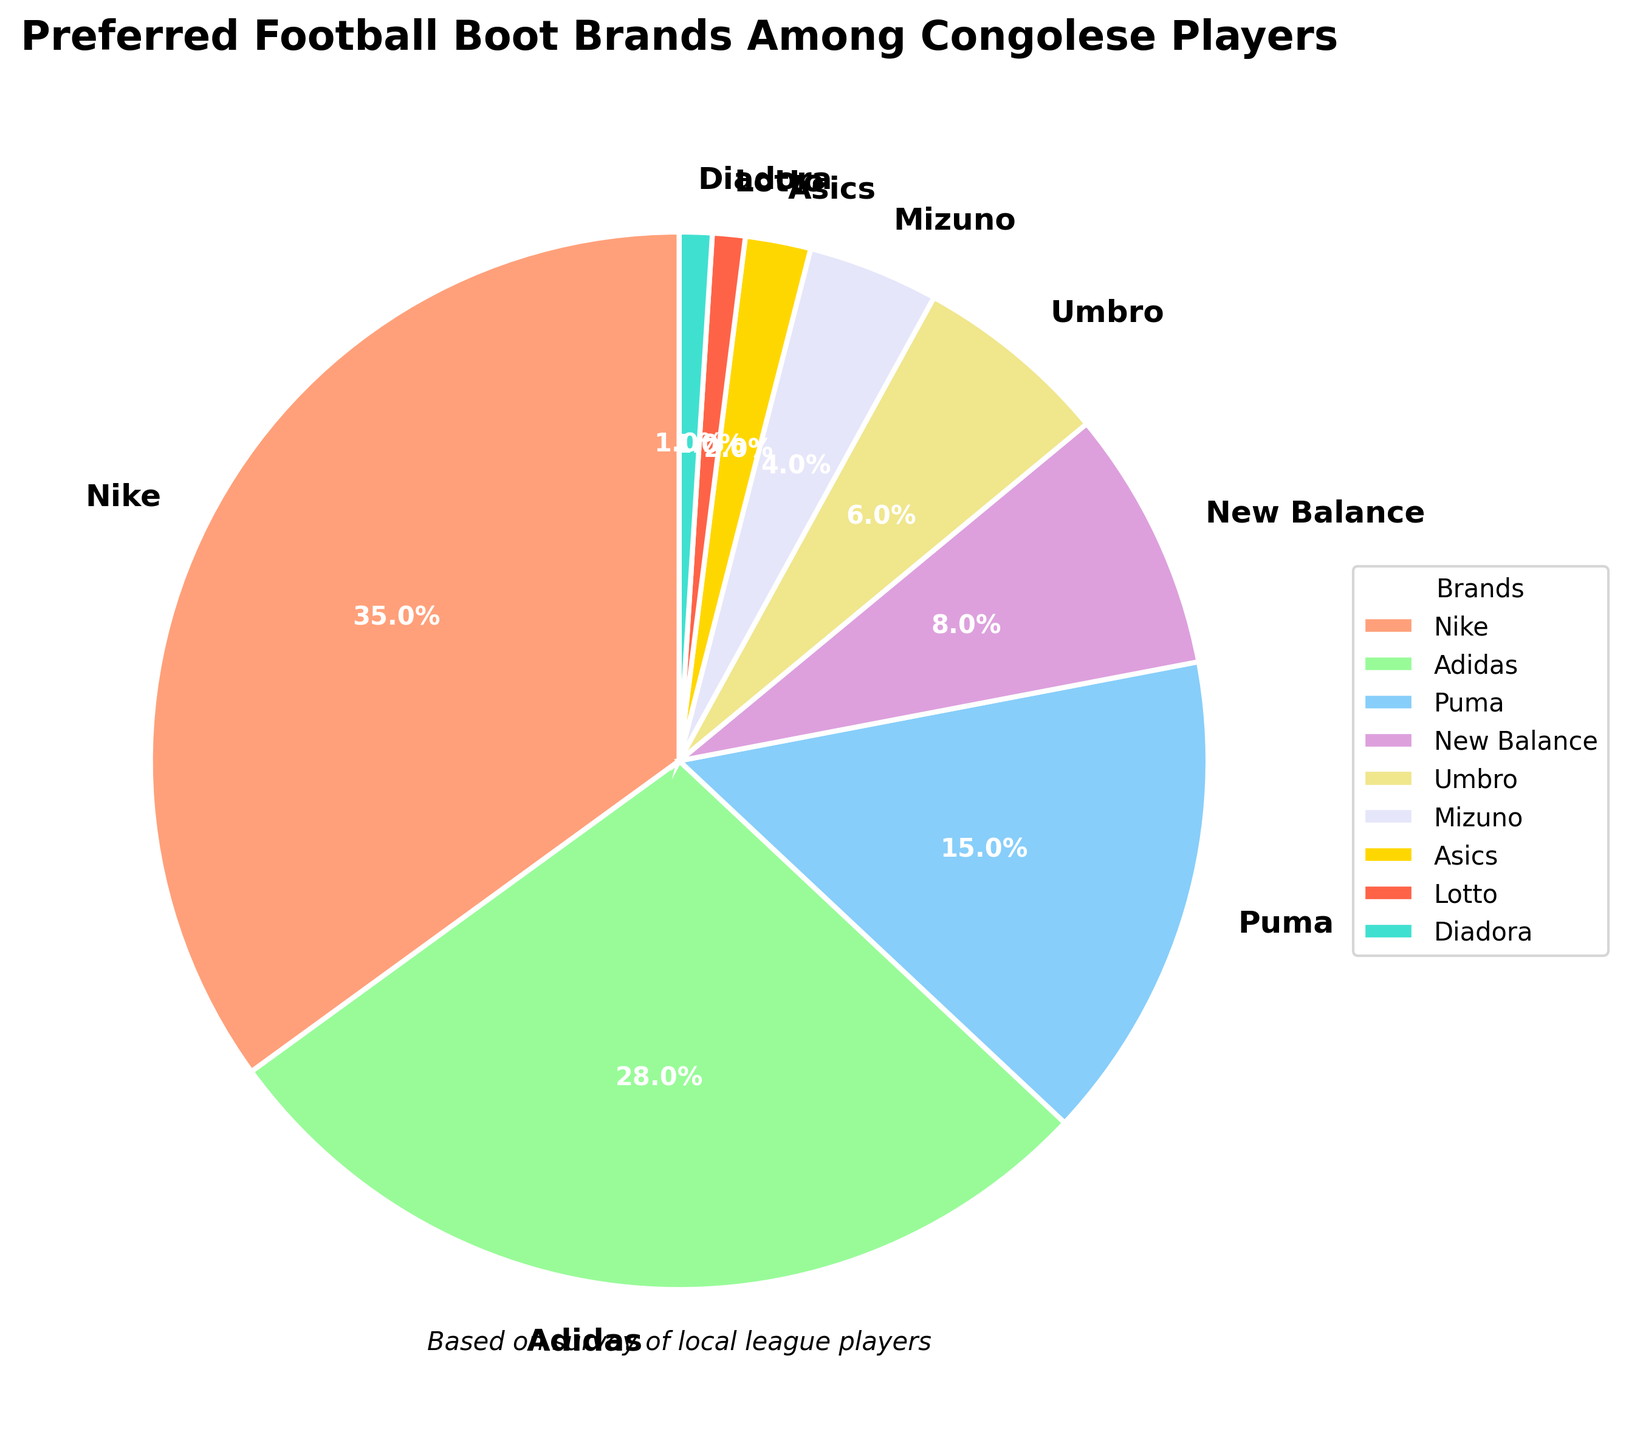What is the most preferred football boot brand among Congolese players? By looking at the pie chart, you see that the largest segment is labeled 'Nike' with a percentage of 35%. Therefore, 'Nike' is the most preferred brand.
Answer: Nike What is the least preferred football boot brand among the players? The smallest segment in the pie chart is split between 'Lotto' and 'Diadora', each labeled with a percentage of 1%. Therefore, 'Lotto' and 'Diadora' are the least preferred brands.
Answer: Lotto, Diadora How much more popular is Nike compared to Puma? Nike has a share of 35% while Puma has a share of 15%. Subtracting Puma's share from Nike's gives 35% - 15% = 20%.
Answer: 20% Which brands constitute more than half of the preference among the players combined? Summing up the top two segments, Nike (35%) and Adidas (28%), we get 35% + 28% = 63%, which is more than half.
Answer: Nike, Adidas How do the percentages of New Balance and Umbro combined compare to Adidas? New Balance is 8% and Umbro is 6%. Adding them gives 8% + 6% = 14%. Adidas stands at 28%. Comparing these, 14% is half of 28%.
Answer: 14%, 28% Which color segment represents Mizuno on the pie chart? By referring to the segment colors and labels in the pie chart, the segment representing Mizuno can be identified. The color of this segment is purple.
Answer: Purple Are there any brands with equal preference percentages? If so, which ones? The pie chart shows two segments each labeled with 1% for both 'Lotto' and 'Diadora'. This means they have equal preference.
Answer: Lotto, Diadora What is the total percentage for the three least preferred brands combined? The least preferred brands are Lotto (1%), Diadora (1%), and Asics (2%). Adding them gives 1% + 1% + 2% = 4%.
Answer: 4% Which brand has a preference percentage closer to Mizuno: New Balance or Umbro? Mizuno has a preference percentage of 4%. New Balance has 8%, and Umbro has 6%. The difference with New Balance is 4% and with Umbro is 2%, so Umbro is closer.
Answer: Umbro How do the preferences of Asics and Lotto combined compare to the preference for Mizuno? Asics and Lotto each have 2% and 1%, respectively. Combined, they make 2% + 1% = 3%, which is 1% lower than Mizuno's 4%.
Answer: 3%, 4% 